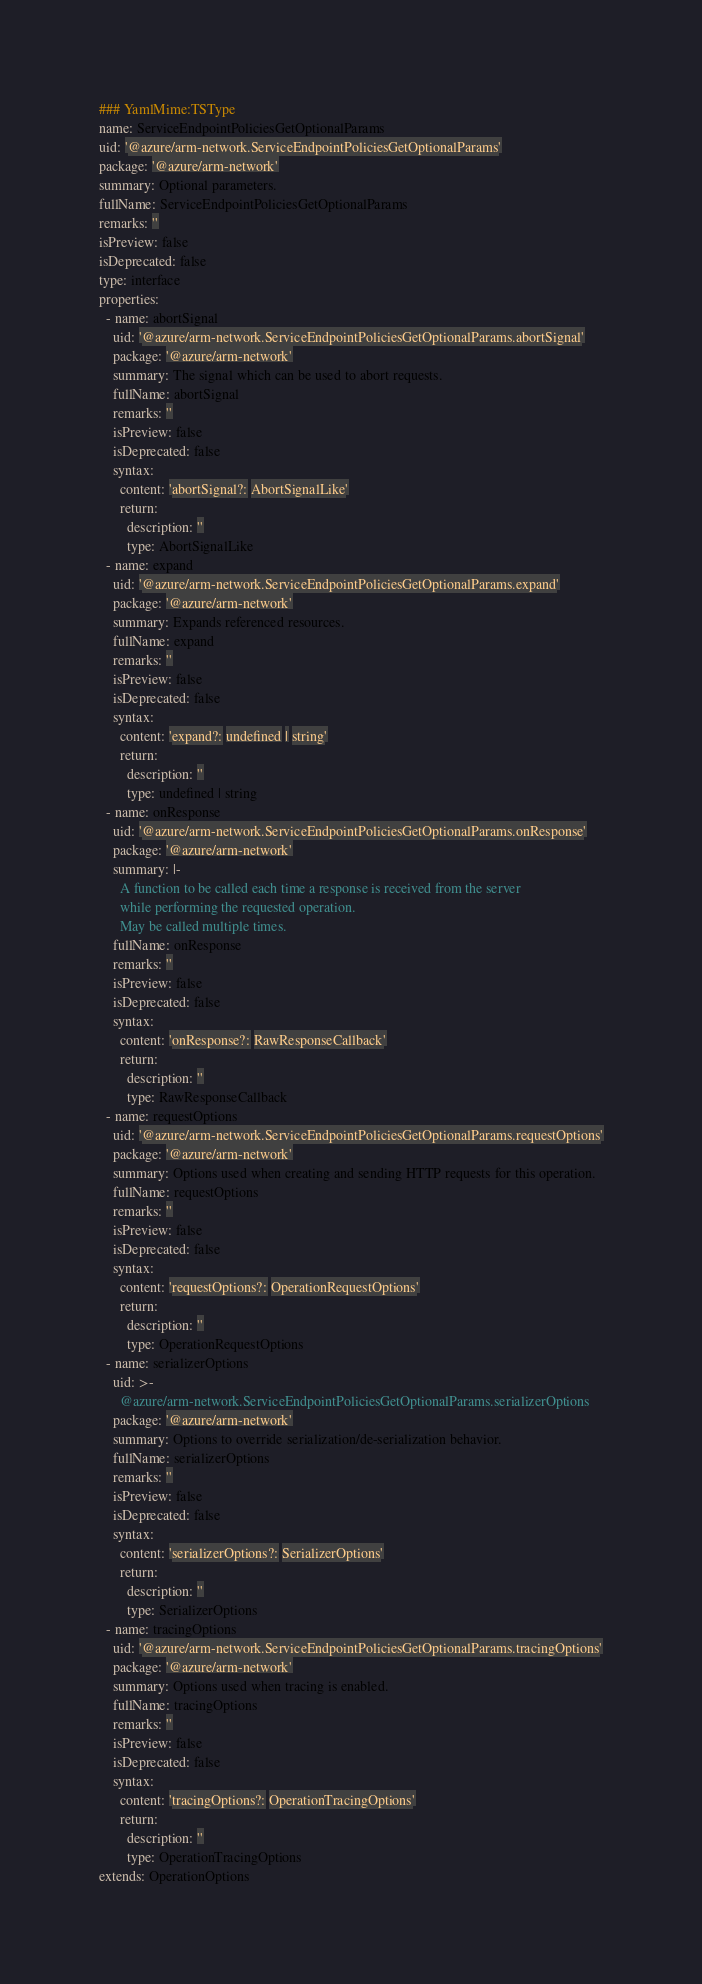<code> <loc_0><loc_0><loc_500><loc_500><_YAML_>### YamlMime:TSType
name: ServiceEndpointPoliciesGetOptionalParams
uid: '@azure/arm-network.ServiceEndpointPoliciesGetOptionalParams'
package: '@azure/arm-network'
summary: Optional parameters.
fullName: ServiceEndpointPoliciesGetOptionalParams
remarks: ''
isPreview: false
isDeprecated: false
type: interface
properties:
  - name: abortSignal
    uid: '@azure/arm-network.ServiceEndpointPoliciesGetOptionalParams.abortSignal'
    package: '@azure/arm-network'
    summary: The signal which can be used to abort requests.
    fullName: abortSignal
    remarks: ''
    isPreview: false
    isDeprecated: false
    syntax:
      content: 'abortSignal?: AbortSignalLike'
      return:
        description: ''
        type: AbortSignalLike
  - name: expand
    uid: '@azure/arm-network.ServiceEndpointPoliciesGetOptionalParams.expand'
    package: '@azure/arm-network'
    summary: Expands referenced resources.
    fullName: expand
    remarks: ''
    isPreview: false
    isDeprecated: false
    syntax:
      content: 'expand?: undefined | string'
      return:
        description: ''
        type: undefined | string
  - name: onResponse
    uid: '@azure/arm-network.ServiceEndpointPoliciesGetOptionalParams.onResponse'
    package: '@azure/arm-network'
    summary: |-
      A function to be called each time a response is received from the server
      while performing the requested operation.
      May be called multiple times.
    fullName: onResponse
    remarks: ''
    isPreview: false
    isDeprecated: false
    syntax:
      content: 'onResponse?: RawResponseCallback'
      return:
        description: ''
        type: RawResponseCallback
  - name: requestOptions
    uid: '@azure/arm-network.ServiceEndpointPoliciesGetOptionalParams.requestOptions'
    package: '@azure/arm-network'
    summary: Options used when creating and sending HTTP requests for this operation.
    fullName: requestOptions
    remarks: ''
    isPreview: false
    isDeprecated: false
    syntax:
      content: 'requestOptions?: OperationRequestOptions'
      return:
        description: ''
        type: OperationRequestOptions
  - name: serializerOptions
    uid: >-
      @azure/arm-network.ServiceEndpointPoliciesGetOptionalParams.serializerOptions
    package: '@azure/arm-network'
    summary: Options to override serialization/de-serialization behavior.
    fullName: serializerOptions
    remarks: ''
    isPreview: false
    isDeprecated: false
    syntax:
      content: 'serializerOptions?: SerializerOptions'
      return:
        description: ''
        type: SerializerOptions
  - name: tracingOptions
    uid: '@azure/arm-network.ServiceEndpointPoliciesGetOptionalParams.tracingOptions'
    package: '@azure/arm-network'
    summary: Options used when tracing is enabled.
    fullName: tracingOptions
    remarks: ''
    isPreview: false
    isDeprecated: false
    syntax:
      content: 'tracingOptions?: OperationTracingOptions'
      return:
        description: ''
        type: OperationTracingOptions
extends: OperationOptions
</code> 